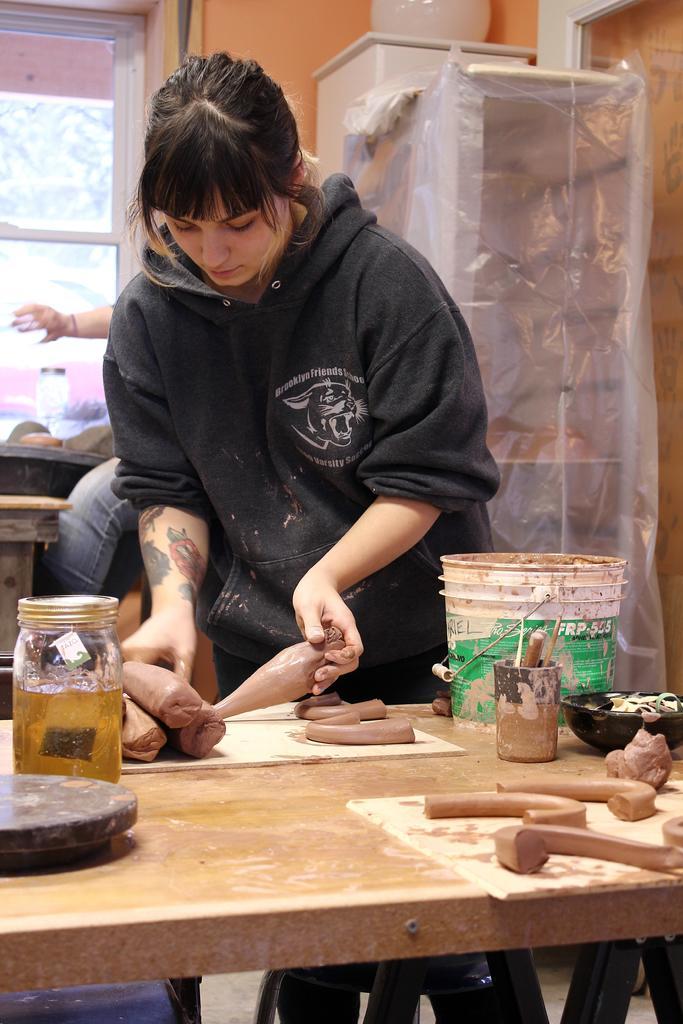Describe this image in one or two sentences. On the table there is bottle,bucket and woman is standing near the table in background there is window. 